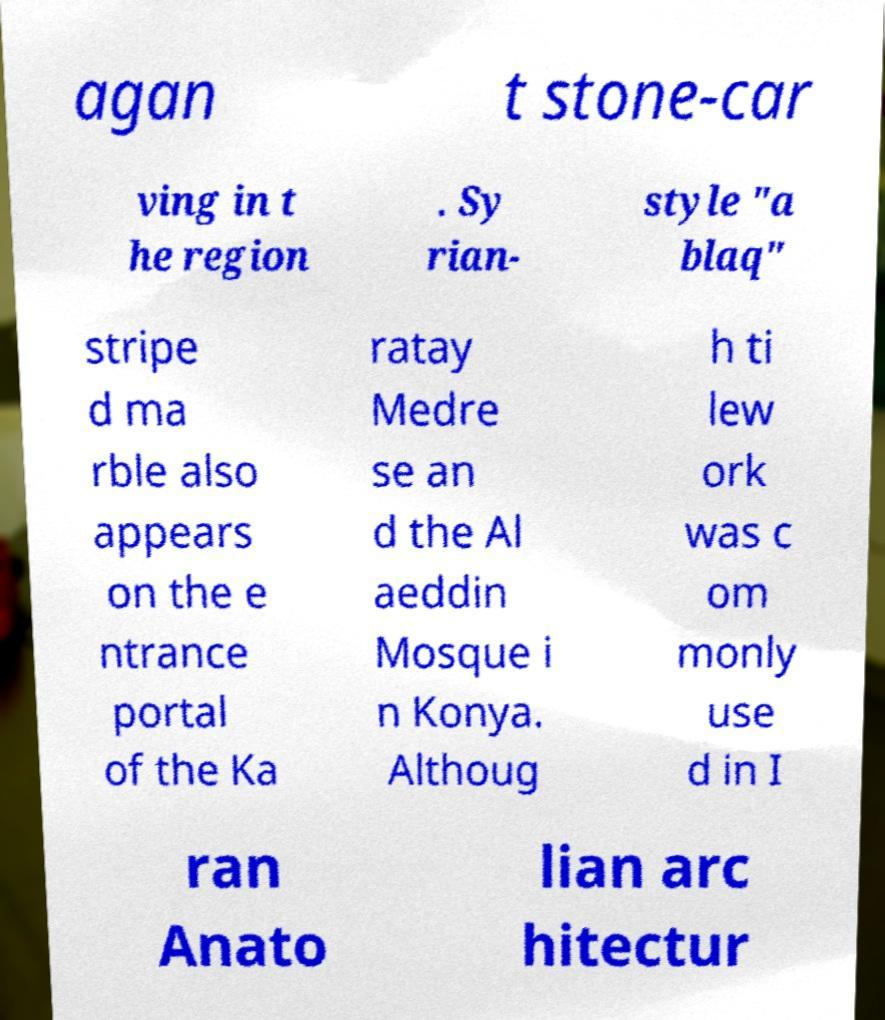Can you read and provide the text displayed in the image?This photo seems to have some interesting text. Can you extract and type it out for me? agan t stone-car ving in t he region . Sy rian- style "a blaq" stripe d ma rble also appears on the e ntrance portal of the Ka ratay Medre se an d the Al aeddin Mosque i n Konya. Althoug h ti lew ork was c om monly use d in I ran Anato lian arc hitectur 